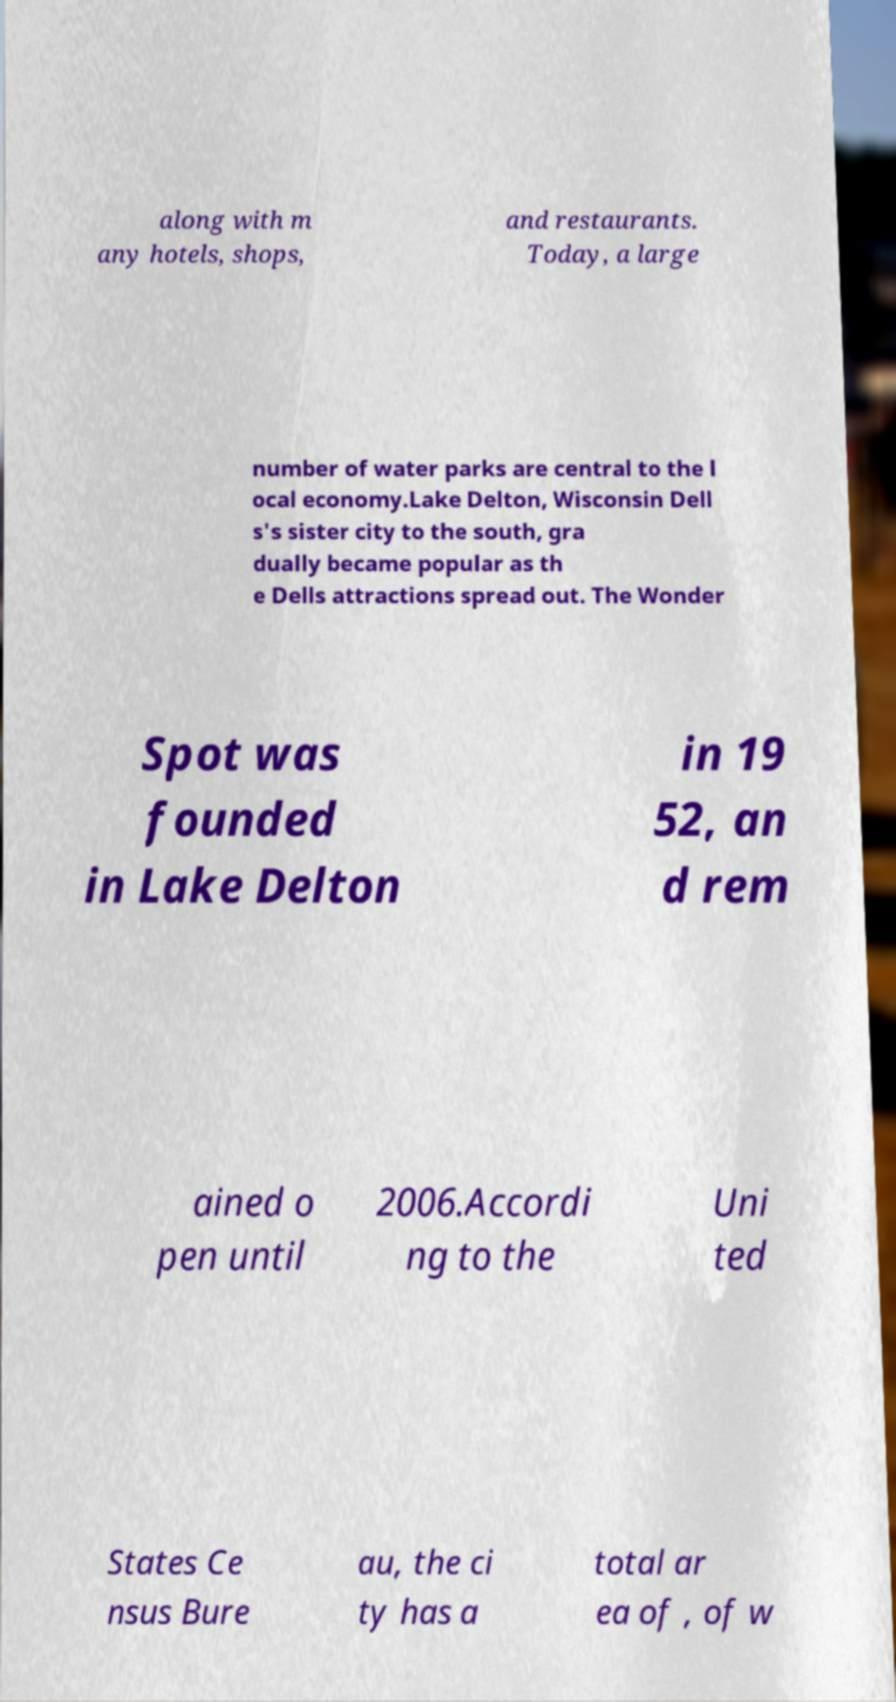Can you accurately transcribe the text from the provided image for me? along with m any hotels, shops, and restaurants. Today, a large number of water parks are central to the l ocal economy.Lake Delton, Wisconsin Dell s's sister city to the south, gra dually became popular as th e Dells attractions spread out. The Wonder Spot was founded in Lake Delton in 19 52, an d rem ained o pen until 2006.Accordi ng to the Uni ted States Ce nsus Bure au, the ci ty has a total ar ea of , of w 